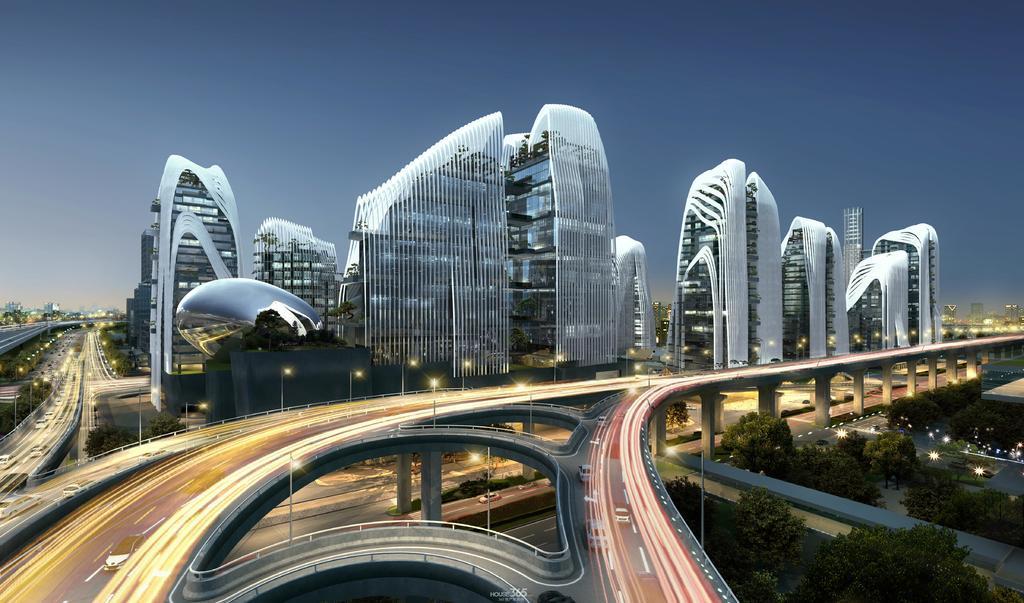Could you give a brief overview of what you see in this image? In this image there is the sky, there are buildings, there is the road, there are vehicles on the road, there are pillars, there are poles, there are streetlights, there are trees, there is text towards the bottom of the image. 